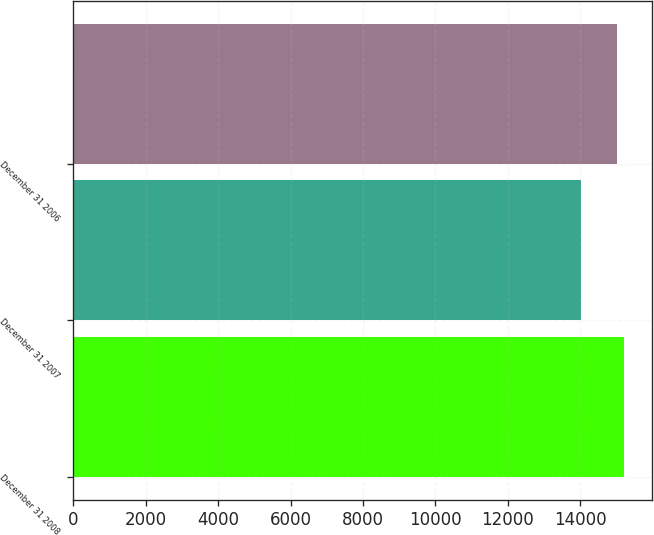<chart> <loc_0><loc_0><loc_500><loc_500><bar_chart><fcel>December 31 2008<fcel>December 31 2007<fcel>December 31 2006<nl><fcel>15207<fcel>14019<fcel>15006<nl></chart> 